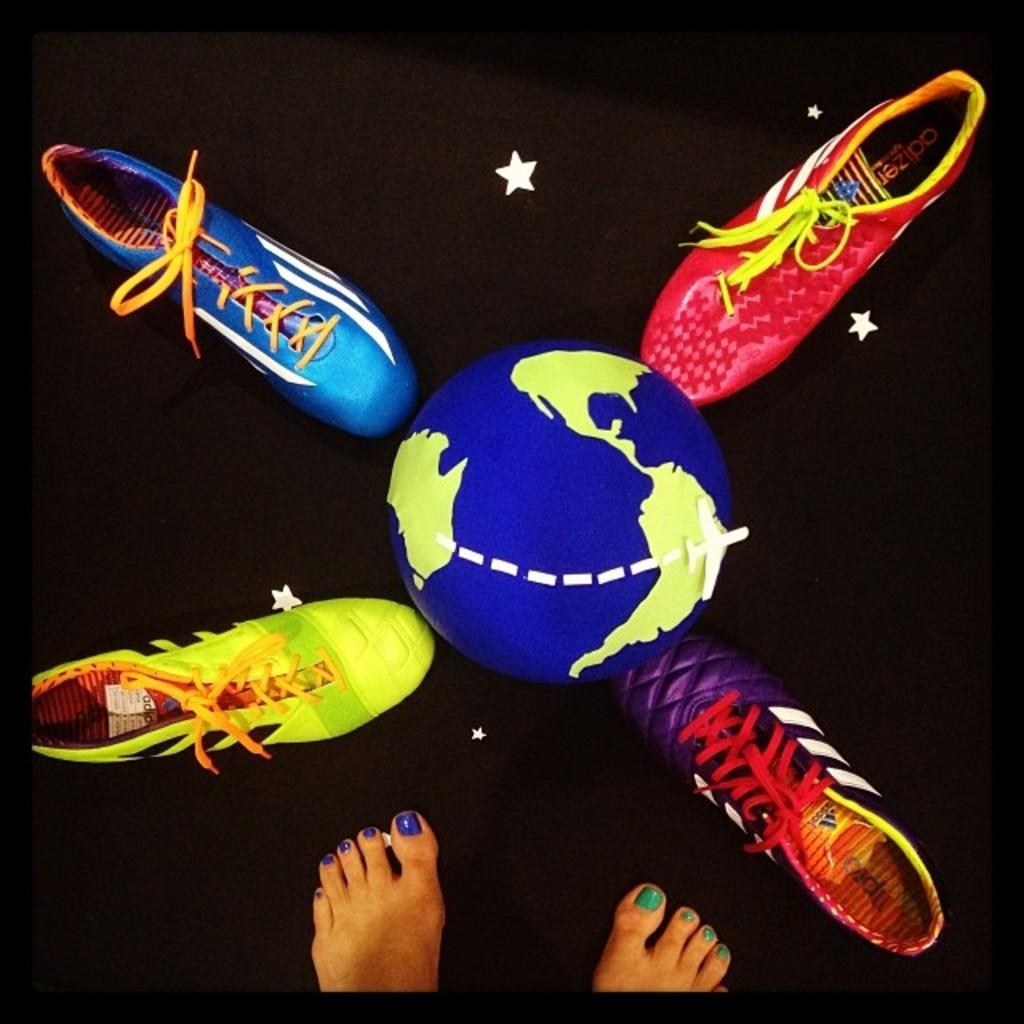What is the main object in the image? There is a football in the image. What else can be seen around the football? Shoes are present around the football. Can you describe any body parts visible in the image? A person's feet are visible in the image. What type of trade is being conducted in the image? There is no trade being conducted in the image; it features a football and shoes. Can you see any windows in the image? There is no window present in the image. 